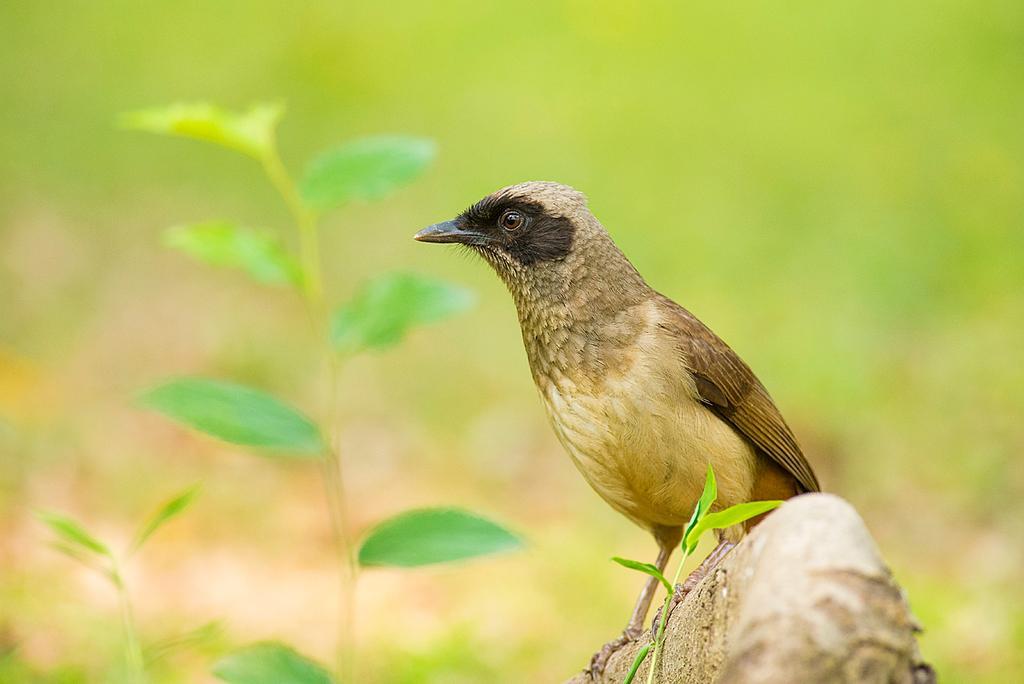Describe this image in one or two sentences. In this image we can see a bird on the wood, there are some plants and the background it is blurred. 